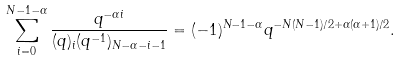<formula> <loc_0><loc_0><loc_500><loc_500>\sum _ { i = 0 } ^ { N - 1 - \alpha } \frac { q ^ { - \alpha i } } { ( q ) _ { i } ( q ^ { - 1 } ) _ { N - \alpha - i - 1 } } = ( - 1 ) ^ { N - 1 - \alpha } q ^ { - N ( N - 1 ) / 2 + \alpha ( \alpha + 1 ) / 2 } .</formula> 